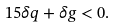Convert formula to latex. <formula><loc_0><loc_0><loc_500><loc_500>1 5 \delta q + \delta g < 0 .</formula> 